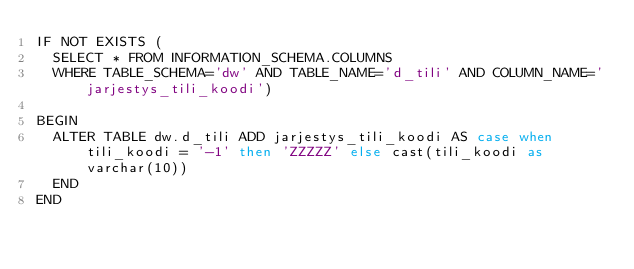Convert code to text. <code><loc_0><loc_0><loc_500><loc_500><_SQL_>IF NOT EXISTS (
	SELECT * FROM INFORMATION_SCHEMA.COLUMNS
	WHERE TABLE_SCHEMA='dw' AND TABLE_NAME='d_tili' AND COLUMN_NAME='jarjestys_tili_koodi')

BEGIN
	ALTER TABLE dw.d_tili ADD jarjestys_tili_koodi AS case when tili_koodi = '-1' then 'ZZZZZ' else cast(tili_koodi as varchar(10))
	END
END
</code> 